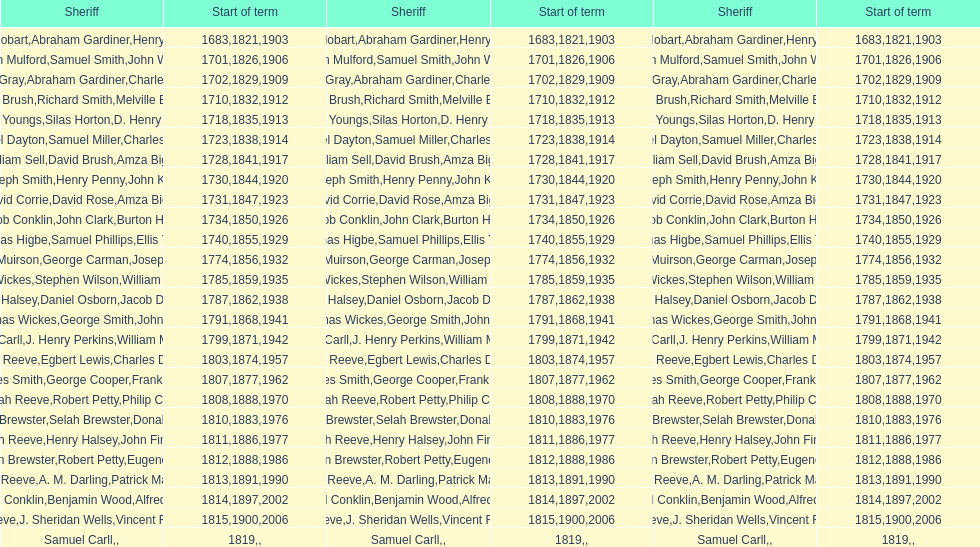How many sheriffs possess the surname biggs? 1. 